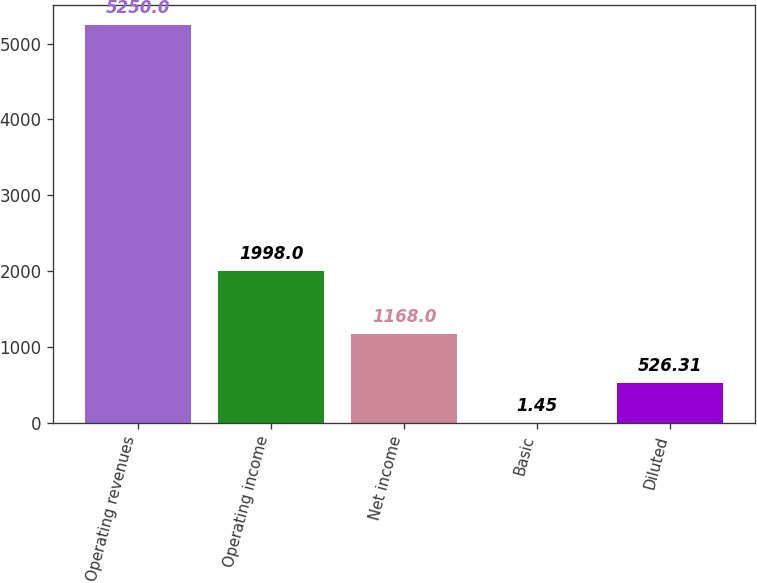<chart> <loc_0><loc_0><loc_500><loc_500><bar_chart><fcel>Operating revenues<fcel>Operating income<fcel>Net income<fcel>Basic<fcel>Diluted<nl><fcel>5250<fcel>1998<fcel>1168<fcel>1.45<fcel>526.31<nl></chart> 